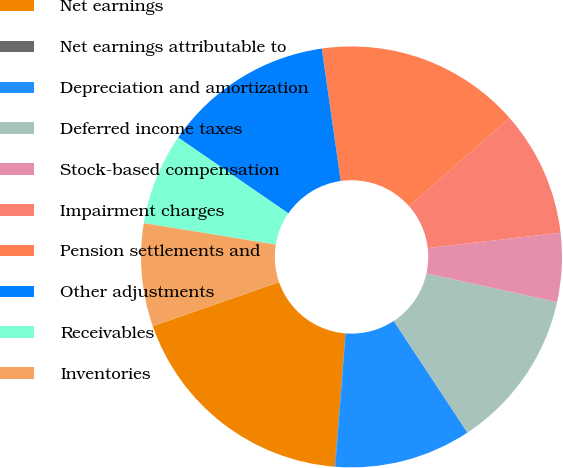<chart> <loc_0><loc_0><loc_500><loc_500><pie_chart><fcel>Net earnings<fcel>Net earnings attributable to<fcel>Depreciation and amortization<fcel>Deferred income taxes<fcel>Stock-based compensation<fcel>Impairment charges<fcel>Pension settlements and<fcel>Other adjustments<fcel>Receivables<fcel>Inventories<nl><fcel>18.39%<fcel>0.04%<fcel>10.52%<fcel>12.27%<fcel>5.28%<fcel>9.65%<fcel>15.77%<fcel>13.15%<fcel>7.03%<fcel>7.9%<nl></chart> 